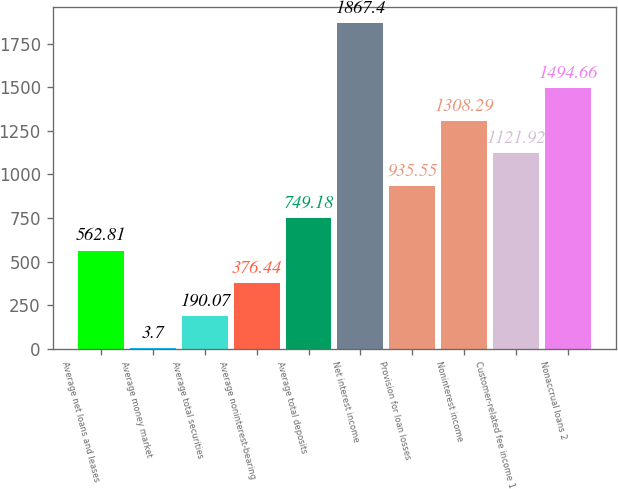<chart> <loc_0><loc_0><loc_500><loc_500><bar_chart><fcel>Average net loans and leases<fcel>Average money market<fcel>Average total securities<fcel>Average noninterest-bearing<fcel>Average total deposits<fcel>Net interest income<fcel>Provision for loan losses<fcel>Noninterest income<fcel>Customer-related fee income 1<fcel>Nonaccrual loans 2<nl><fcel>562.81<fcel>3.7<fcel>190.07<fcel>376.44<fcel>749.18<fcel>1867.4<fcel>935.55<fcel>1308.29<fcel>1121.92<fcel>1494.66<nl></chart> 